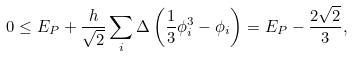Convert formula to latex. <formula><loc_0><loc_0><loc_500><loc_500>0 \leq E _ { P } + \frac { h } { \sqrt { 2 } } \sum _ { i } \Delta \left ( \frac { 1 } { 3 } \phi _ { i } ^ { 3 } - \phi _ { i } \right ) = E _ { P } - \frac { 2 \sqrt { 2 } } { 3 } ,</formula> 